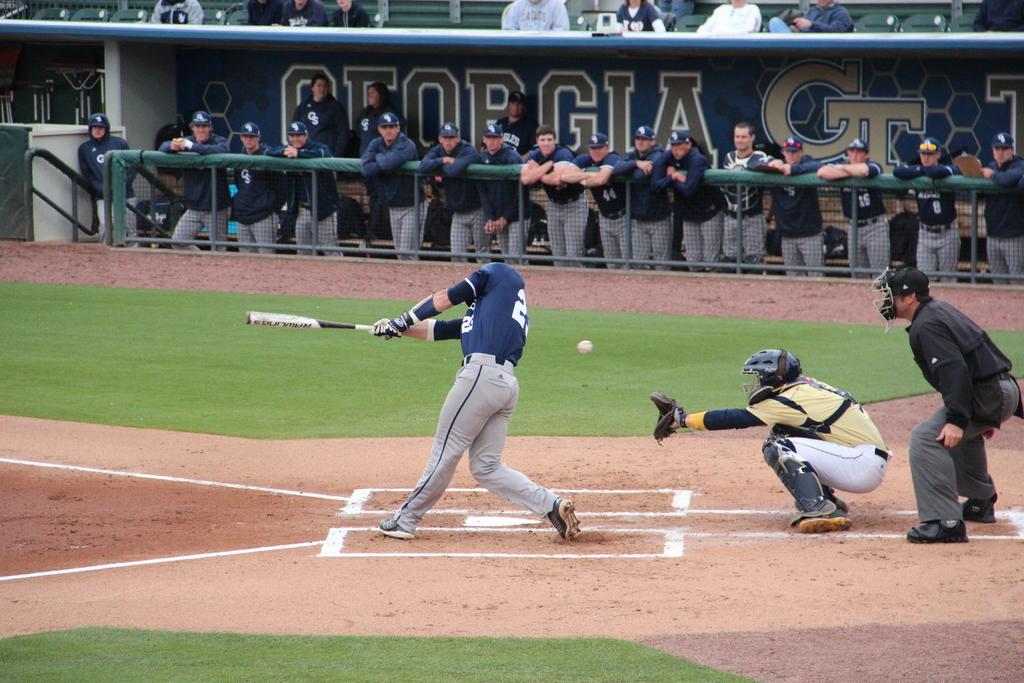What state does this game take place in?
Your response must be concise. Georgia. What is the furthest to the right in the dugouts number?
Your response must be concise. 8. 